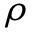Convert formula to latex. <formula><loc_0><loc_0><loc_500><loc_500>\rho</formula> 